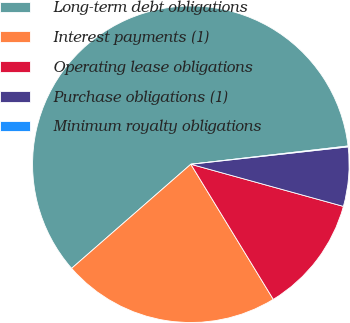<chart> <loc_0><loc_0><loc_500><loc_500><pie_chart><fcel>Long-term debt obligations<fcel>Interest payments (1)<fcel>Operating lease obligations<fcel>Purchase obligations (1)<fcel>Minimum royalty obligations<nl><fcel>59.59%<fcel>22.3%<fcel>11.99%<fcel>6.04%<fcel>0.09%<nl></chart> 